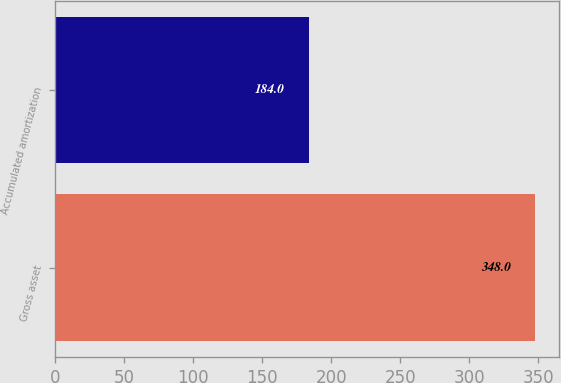Convert chart to OTSL. <chart><loc_0><loc_0><loc_500><loc_500><bar_chart><fcel>Gross asset<fcel>Accumulated amortization<nl><fcel>348<fcel>184<nl></chart> 